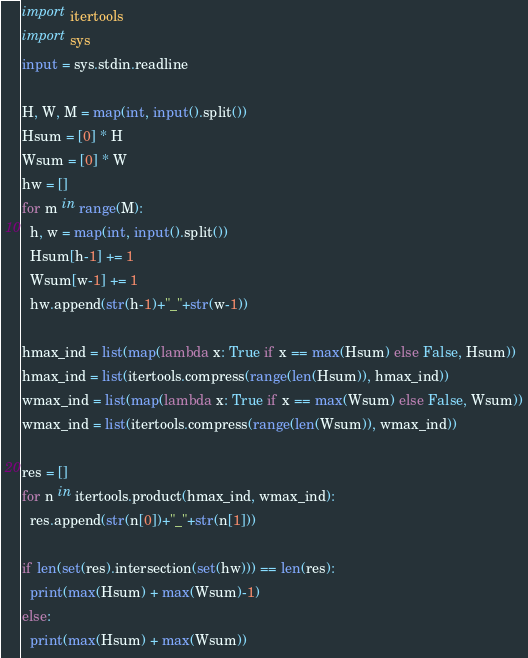<code> <loc_0><loc_0><loc_500><loc_500><_Python_>import itertools
import sys
input = sys.stdin.readline

H, W, M = map(int, input().split())
Hsum = [0] * H
Wsum = [0] * W
hw = []
for m in range(M):
  h, w = map(int, input().split())
  Hsum[h-1] += 1
  Wsum[w-1] += 1
  hw.append(str(h-1)+"_"+str(w-1))

hmax_ind = list(map(lambda x: True if x == max(Hsum) else False, Hsum))
hmax_ind = list(itertools.compress(range(len(Hsum)), hmax_ind))
wmax_ind = list(map(lambda x: True if x == max(Wsum) else False, Wsum))
wmax_ind = list(itertools.compress(range(len(Wsum)), wmax_ind))
 
res = []
for n in itertools.product(hmax_ind, wmax_ind):
  res.append(str(n[0])+"_"+str(n[1]))

if len(set(res).intersection(set(hw))) == len(res):
  print(max(Hsum) + max(Wsum)-1)
else:
  print(max(Hsum) + max(Wsum))</code> 